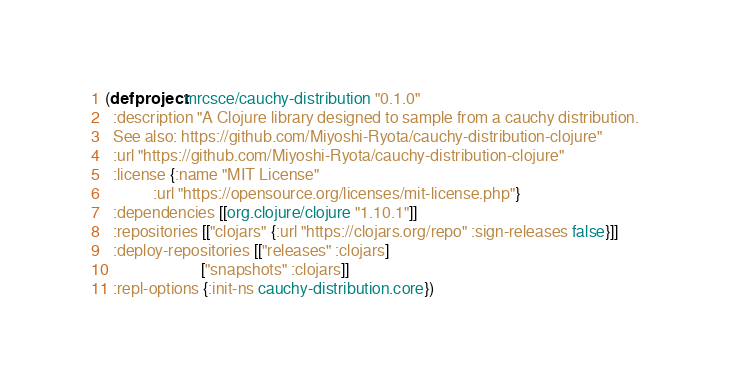Convert code to text. <code><loc_0><loc_0><loc_500><loc_500><_Clojure_>(defproject mrcsce/cauchy-distribution "0.1.0"
  :description "A Clojure library designed to sample from a cauchy distribution.
  See also: https://github.com/Miyoshi-Ryota/cauchy-distribution-clojure"
  :url "https://github.com/Miyoshi-Ryota/cauchy-distribution-clojure"
  :license {:name "MIT License"
            :url "https://opensource.org/licenses/mit-license.php"}
  :dependencies [[org.clojure/clojure "1.10.1"]]
  :repositories [["clojars" {:url "https://clojars.org/repo" :sign-releases false}]]
  :deploy-repositories [["releases" :clojars]
                        ["snapshots" :clojars]]
  :repl-options {:init-ns cauchy-distribution.core})
</code> 